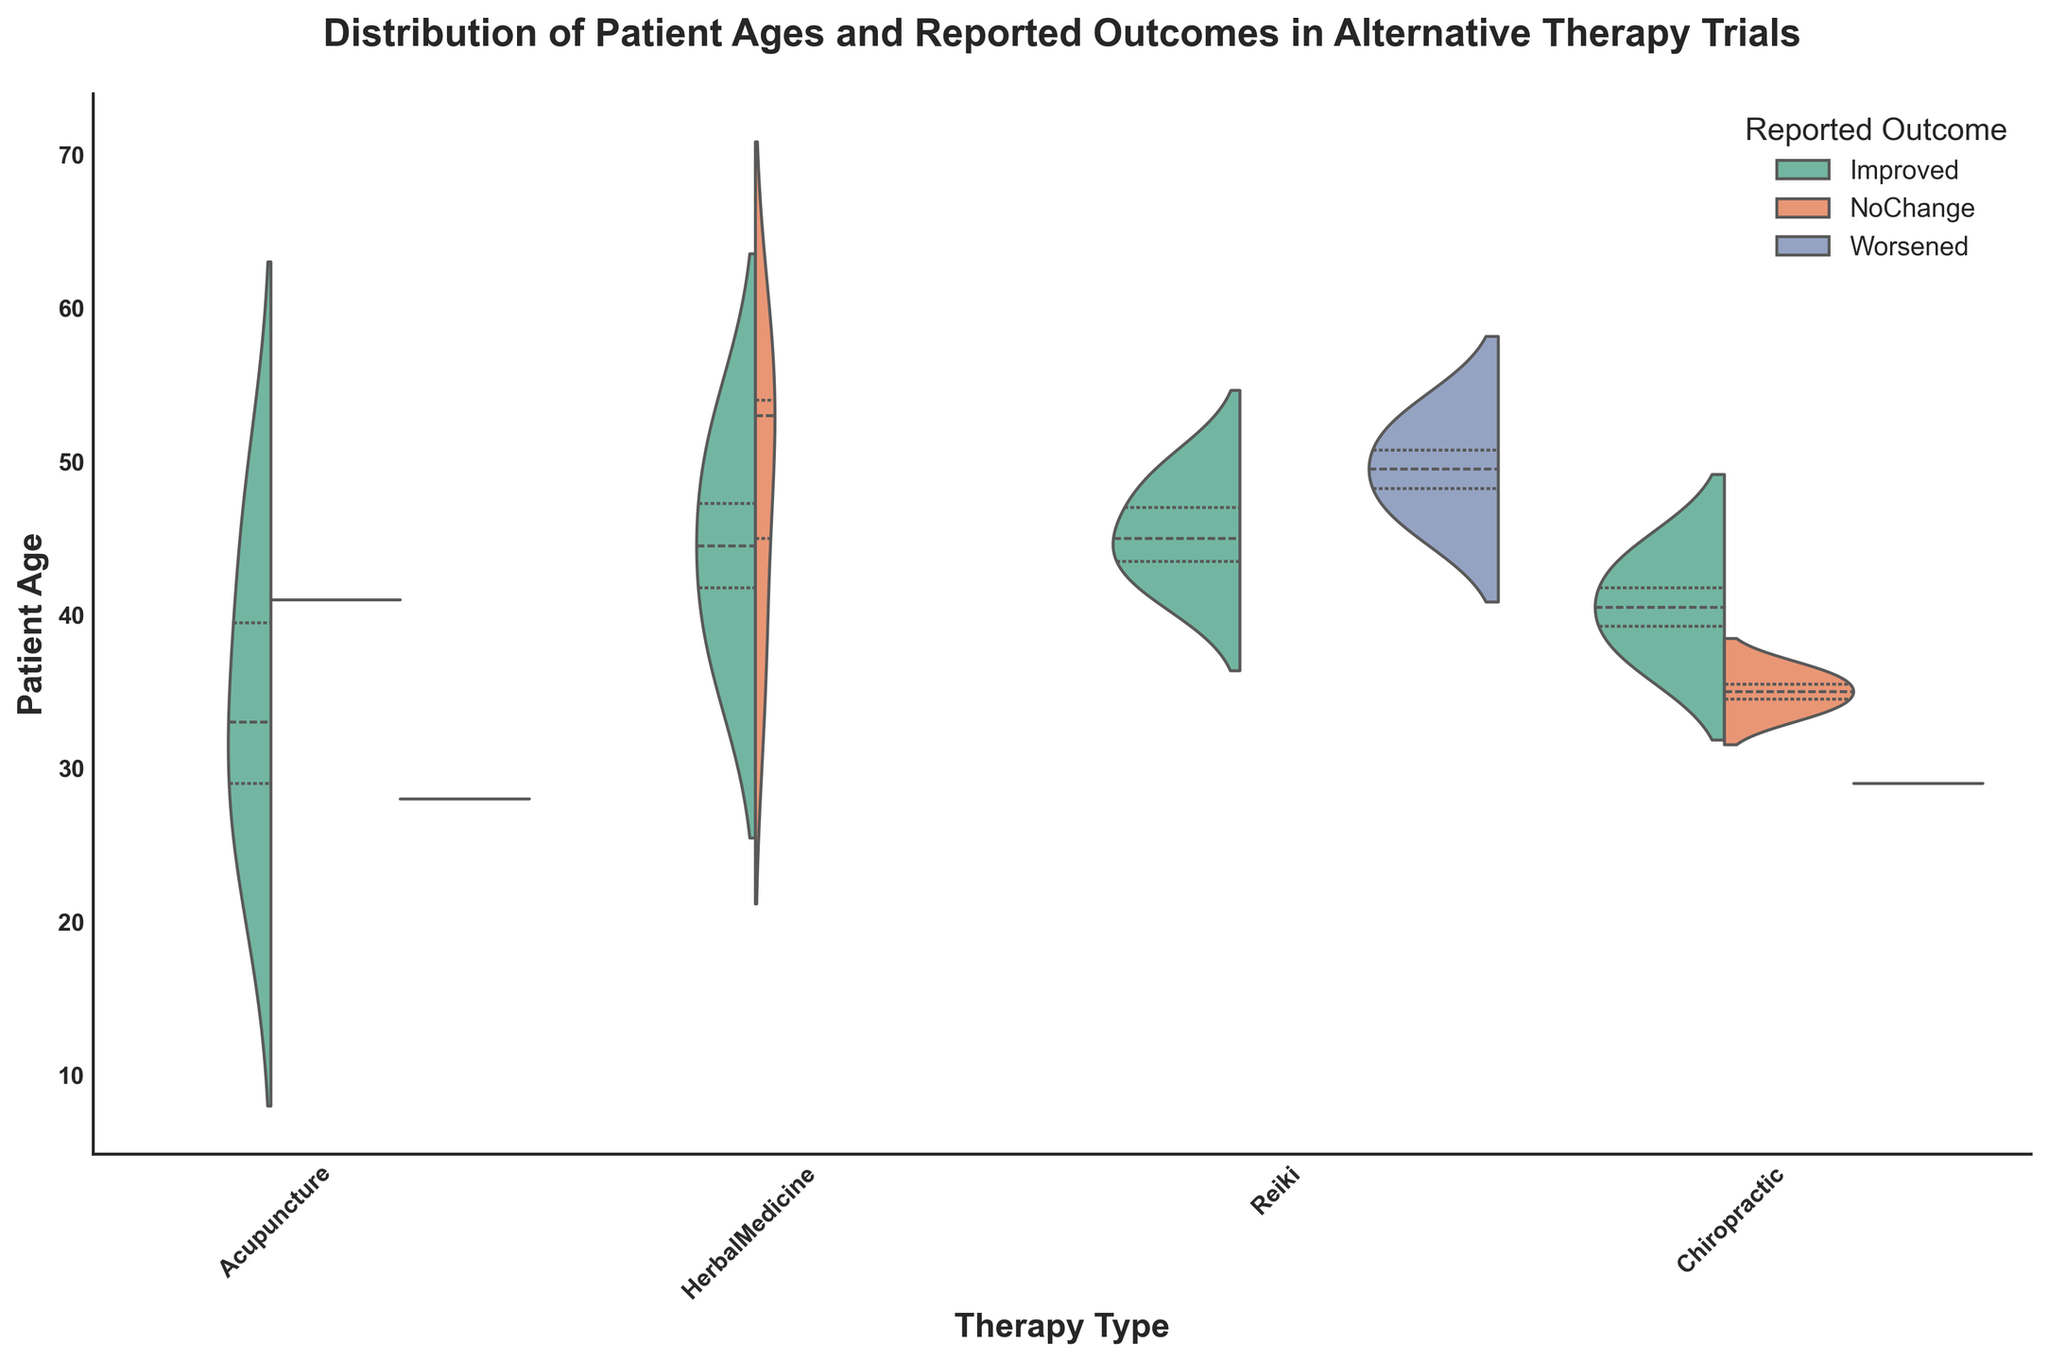What's the title of the figure? The title is located at the top of the figure, and it summarizes the content being displayed.
Answer: Distribution of Patient Ages and Reported Outcomes in Alternative Therapy Trials Which therapy type appears to have the highest range of patient ages? By visually inspecting the spread of the violins, we can see which therapy type has the broadest spread along the y-axis representing patient ages.
Answer: HerbalMedicine How many therapy types are displayed in the figure? Count the distinct categories on the x-axis that represent different therapy types.
Answer: Four Which outcome has the most green color representation in Acupuncture? The green color represents "Improved". By looking at the violin for Acupuncture, we can see how much of it is taken up by the green color compared to other colors.
Answer: Improved Is the "Improved" outcome represented in each therapy type? Inspect each of the therapy types (Acupuncture, HerbalMedicine, Reiki, Chiropractic) to see if the green sections are present in each violin plot.
Answer: Yes In which therapy type do you see the patients' ages mostly between 30 and 50 for the "NoChange" outcome? Look at the orange section (which represents "NoChange") within the violin plots and see where it primarily falls along the y-axis (patient ages) for each therapy type.
Answer: Chiropractic How does the distribution of reported outcomes vary between Acupuncture and Reiki? Compare the shapes and color compositions (green for "Improved", orange for "NoChange", blue for "Worsened") between the violins for Acupuncture and Reiki.
Answer: Acupuncture shows a larger green section for "Improved" and a smaller blue section for "Worsened" compared to Reiki Which therapy type shows a higher median age for patients with the "Worsened" outcome? The median is indicated by the thickest part of the violin plot. Compare the thickest part of the blue section across therapy types.
Answer: Reiki How does the patient age distribution for "NoChange" and "Improved" outcomes compare in Chiropractic? Look at the orange section ("NoChange") and green section ("Improved") in the Chiropractic violin plot to see how their shapes and positions compare along the y-axis.
Answer: "Improved" outcomes show a broader age range, while "NoChange" has a narrower range What is the primary age range for patients in HerbalMedicine therapy with "Improved" outcomes? Inspect the green section within the HerbalMedicine violin, focusing on its span and central tendencies along the y-axis.
Answer: Approximately 40-50 